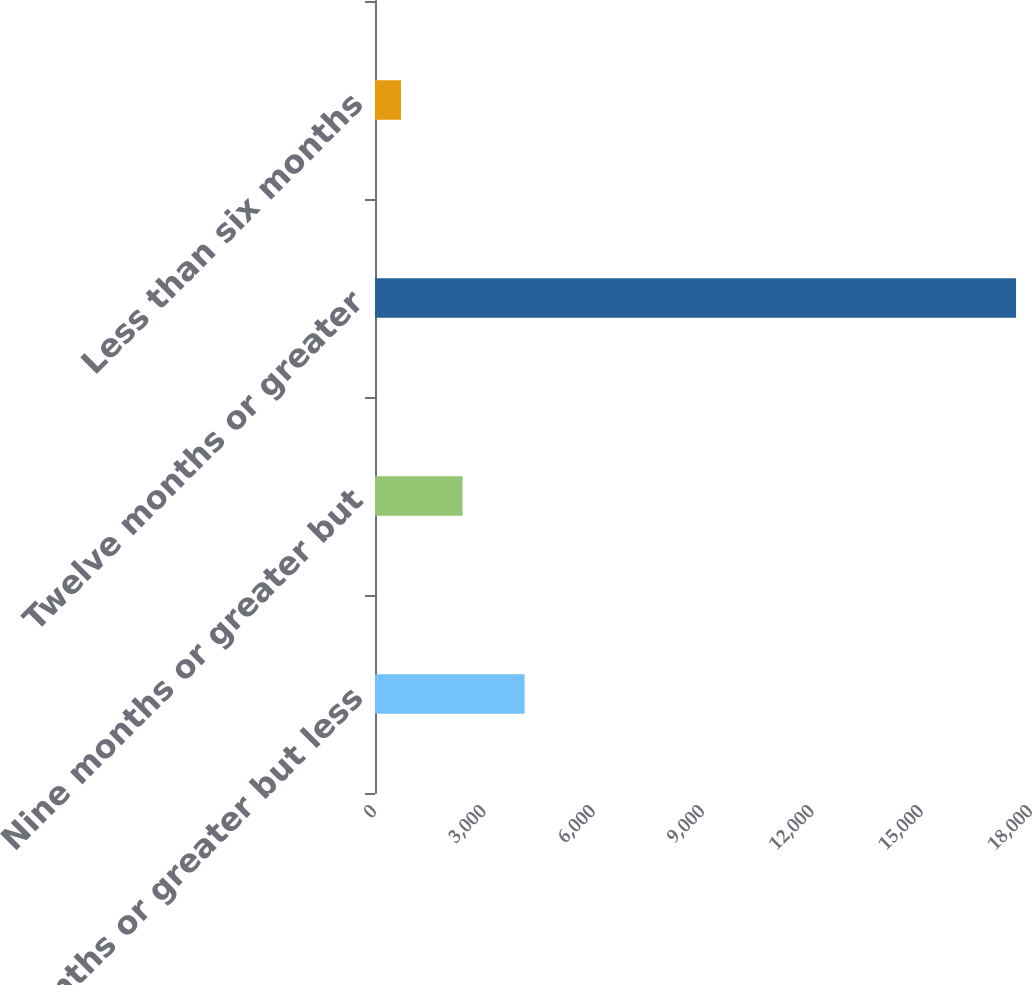<chart> <loc_0><loc_0><loc_500><loc_500><bar_chart><fcel>Six months or greater but less<fcel>Nine months or greater but<fcel>Twelve months or greater<fcel>Less than six months<nl><fcel>4104<fcel>2401.6<fcel>17590<fcel>714<nl></chart> 